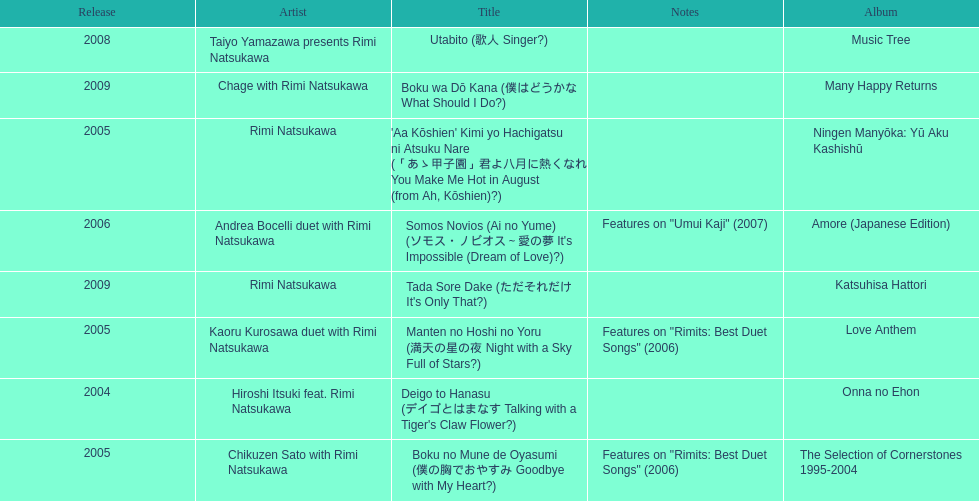What year was the first title released? 2004. 